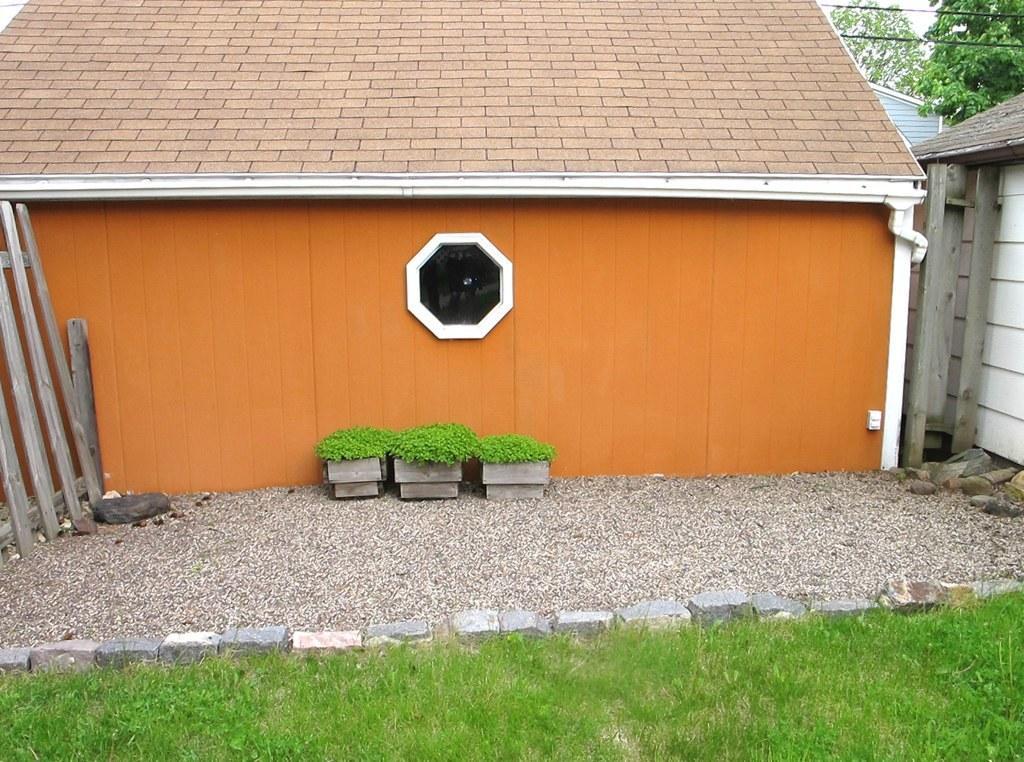In one or two sentences, can you explain what this image depicts? In this picture we can see houses, plants, wooden planks, grass and stones. In the background of the image we can see trees, wires and sky. 